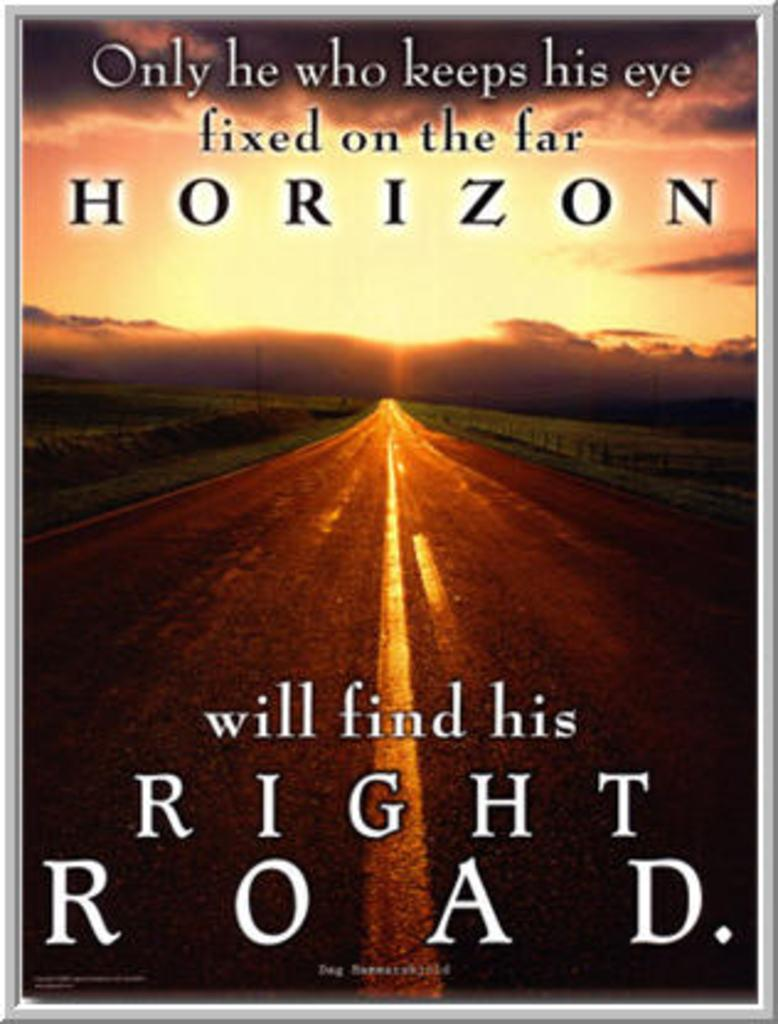<image>
Write a terse but informative summary of the picture. A card with a street shown and Horizon in large letters. 